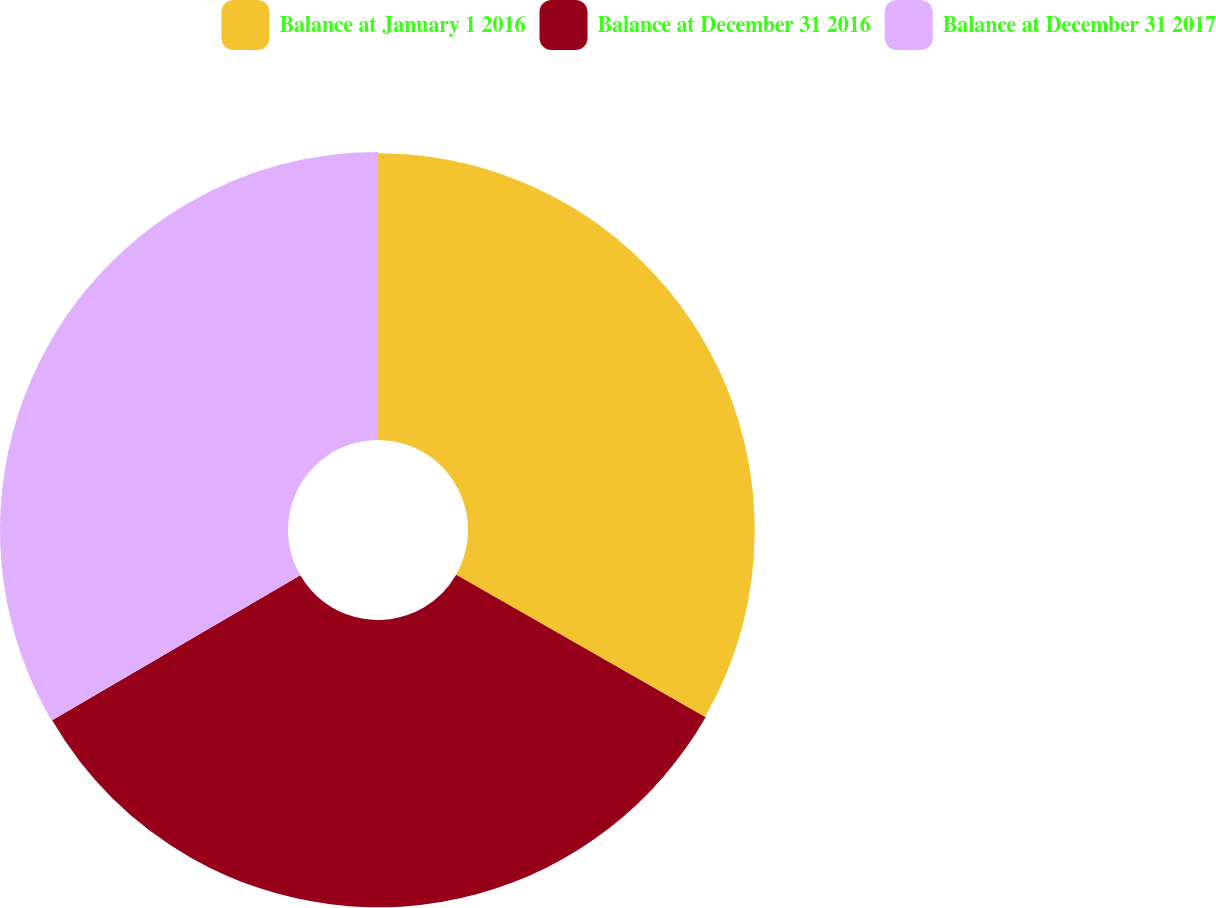<chart> <loc_0><loc_0><loc_500><loc_500><pie_chart><fcel>Balance at January 1 2016<fcel>Balance at December 31 2016<fcel>Balance at December 31 2017<nl><fcel>33.26%<fcel>33.33%<fcel>33.41%<nl></chart> 